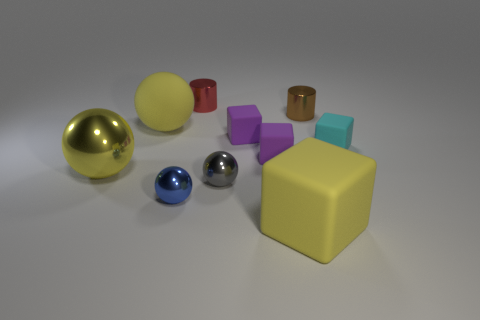Add 2 large yellow metal things. How many large yellow metal things exist? 3 Subtract all gray balls. How many balls are left? 3 Subtract all gray metallic spheres. How many spheres are left? 3 Subtract 0 purple balls. How many objects are left? 10 Subtract all spheres. How many objects are left? 6 Subtract 2 balls. How many balls are left? 2 Subtract all brown cubes. Subtract all red cylinders. How many cubes are left? 4 Subtract all green cubes. How many brown cylinders are left? 1 Subtract all yellow shiny balls. Subtract all small brown objects. How many objects are left? 8 Add 3 blue objects. How many blue objects are left? 4 